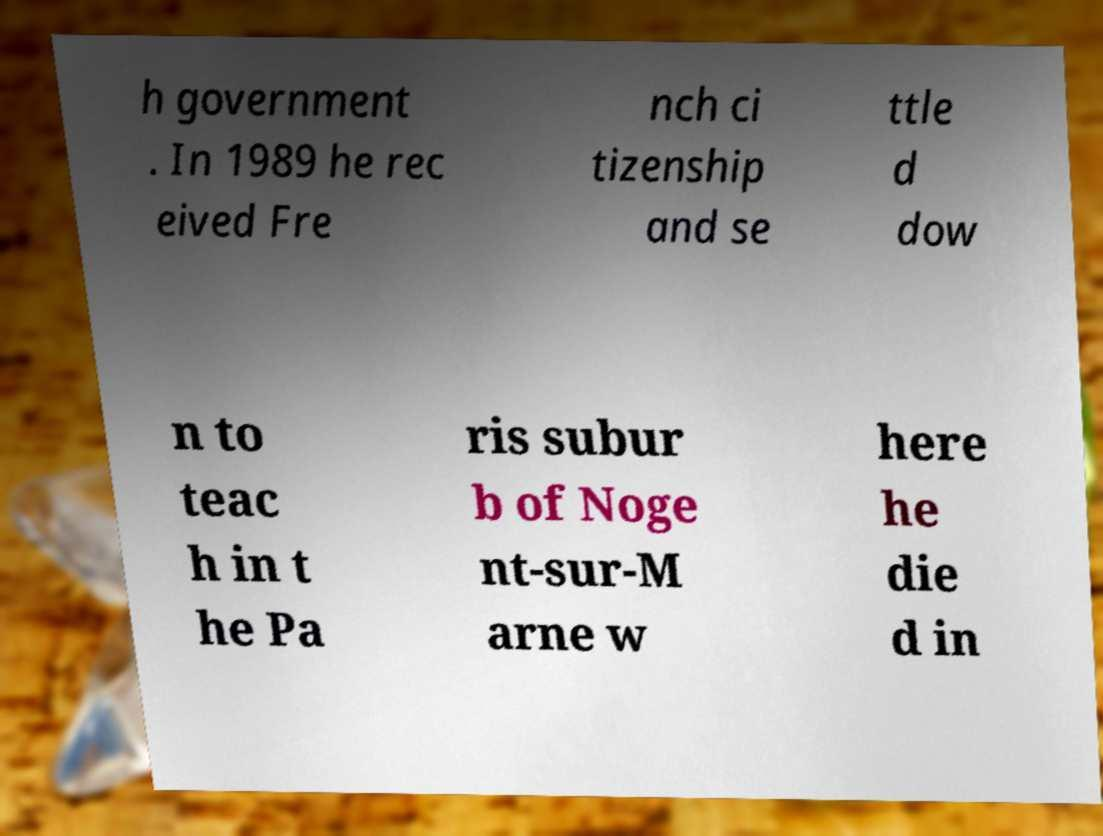There's text embedded in this image that I need extracted. Can you transcribe it verbatim? h government . In 1989 he rec eived Fre nch ci tizenship and se ttle d dow n to teac h in t he Pa ris subur b of Noge nt-sur-M arne w here he die d in 